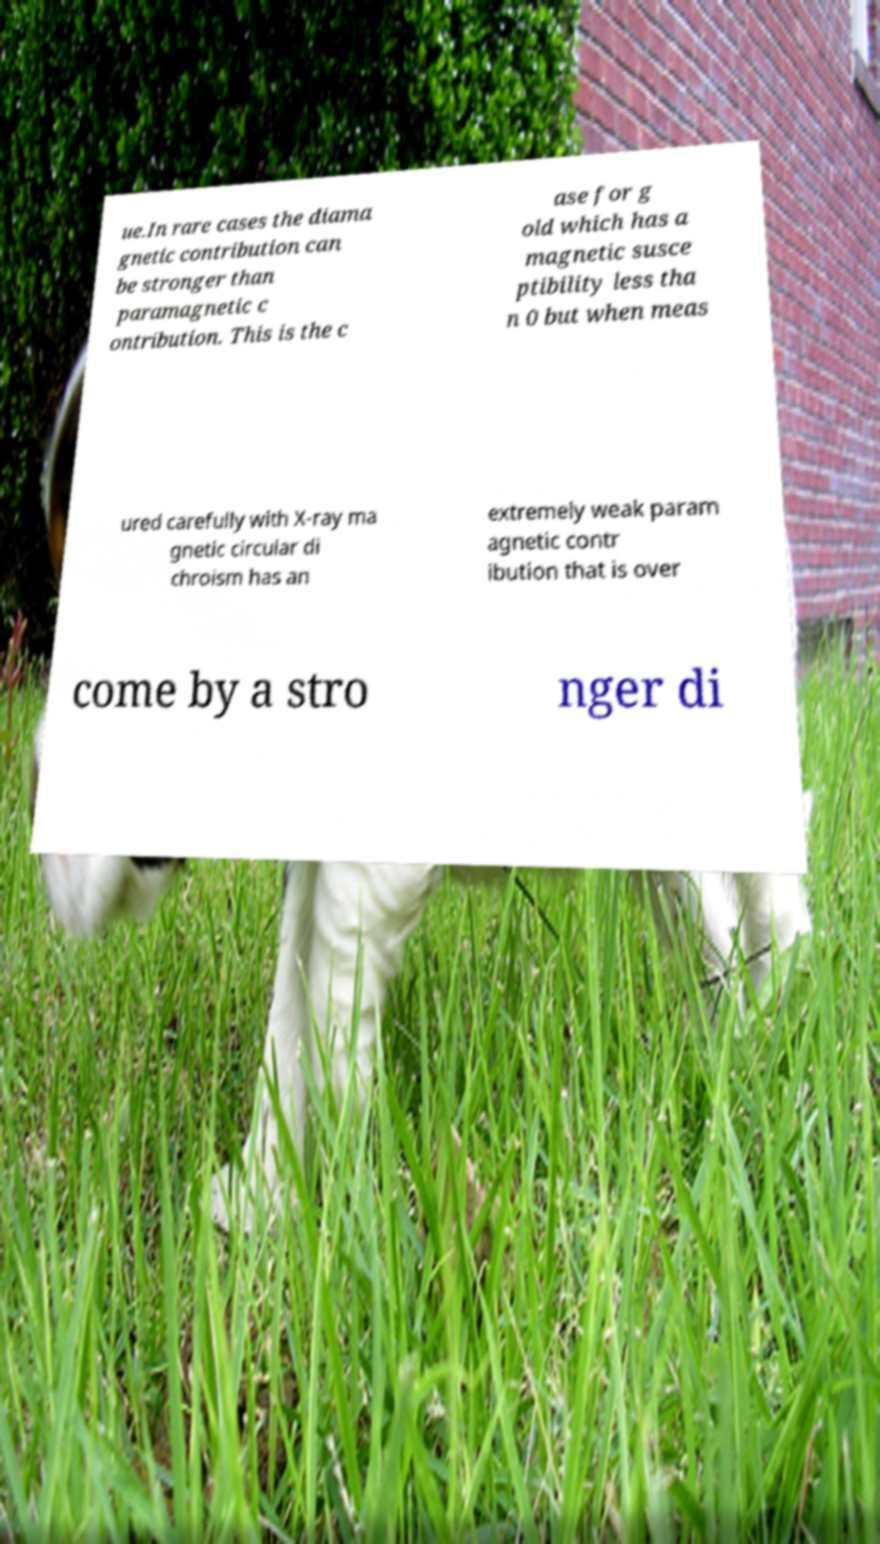There's text embedded in this image that I need extracted. Can you transcribe it verbatim? ue.In rare cases the diama gnetic contribution can be stronger than paramagnetic c ontribution. This is the c ase for g old which has a magnetic susce ptibility less tha n 0 but when meas ured carefully with X-ray ma gnetic circular di chroism has an extremely weak param agnetic contr ibution that is over come by a stro nger di 